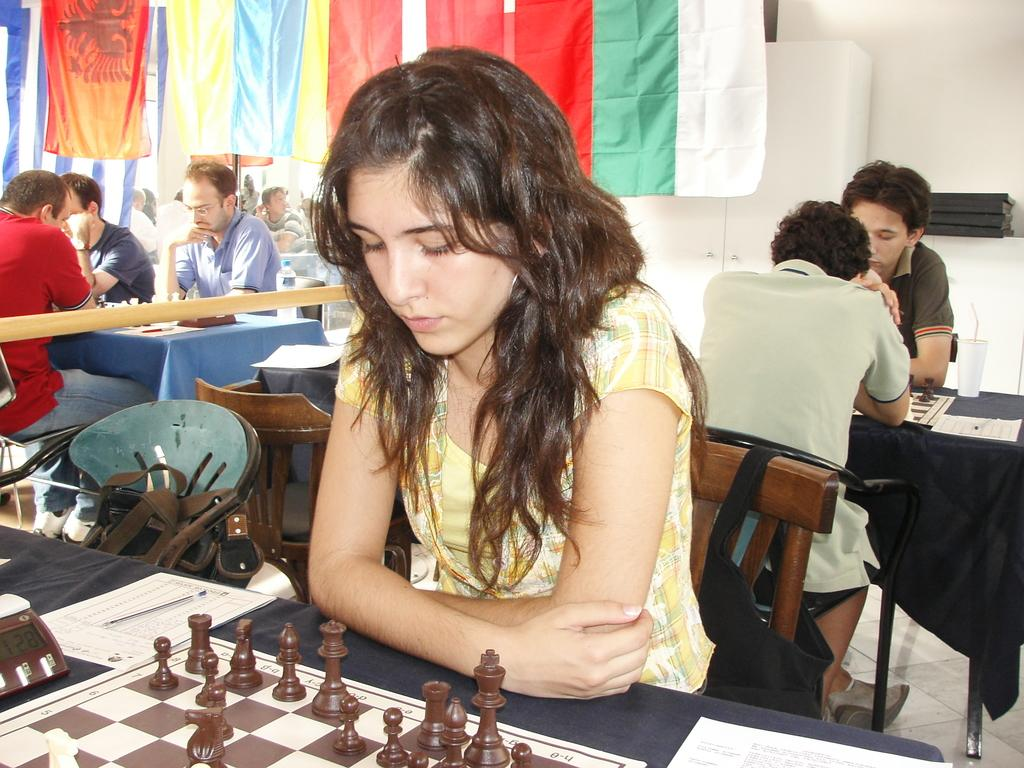What activity are the people in the image engaged in? The people in the image are playing chess. What is on the table that the people are using for the game? There are chess boards on the table. What can be seen at the top of the image? There are flags at the top of the image. What furniture is present in the image? There are chairs in the image. What type of seed is being used to grow celery in the image? There is no celery or seed present in the image; it features people playing chess with chess boards on a table. How many geese are visible in the image? There are no geese present in the image. 